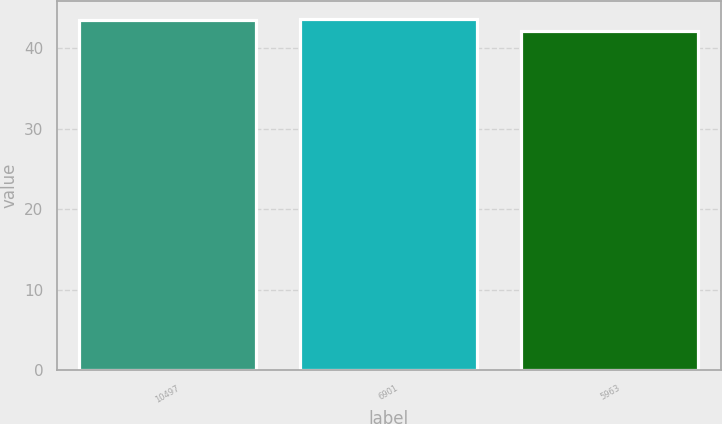<chart> <loc_0><loc_0><loc_500><loc_500><bar_chart><fcel>10497<fcel>6901<fcel>5963<nl><fcel>43.5<fcel>43.7<fcel>42.1<nl></chart> 